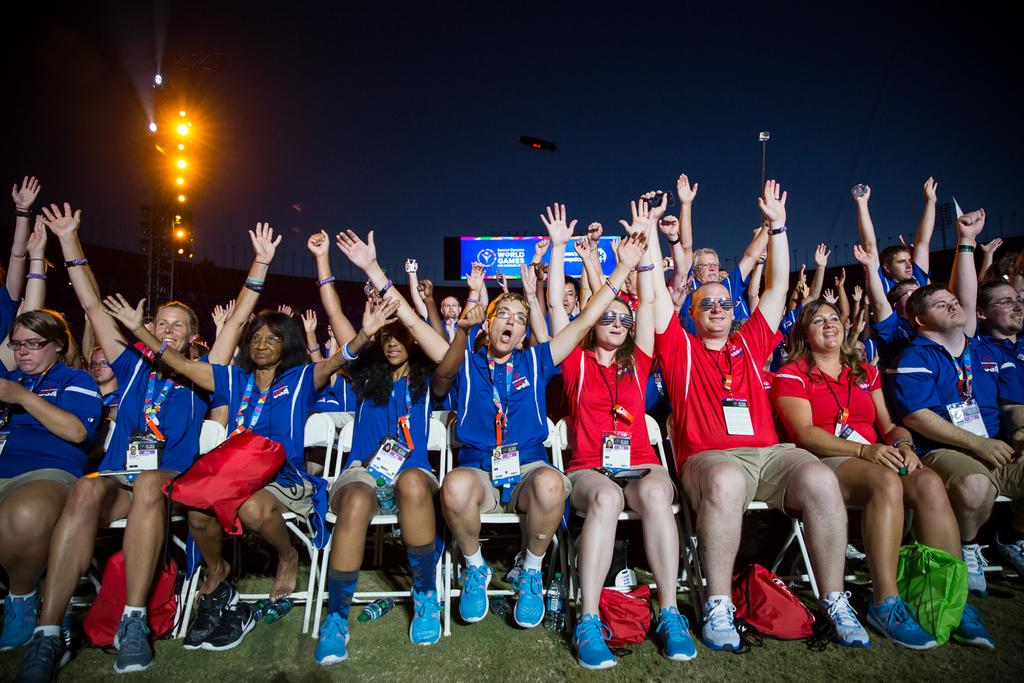What are the people in the image doing? The people in the image are sitting on chairs. What can be seen on the board in the image? The facts do not specify what is on the board, so we cannot answer that question definitively. What type of illumination is present in the image? There are lights present in the image. How many men are adjusting the group in the image? There is no mention of men or adjustments in the image, so we cannot answer that question. 